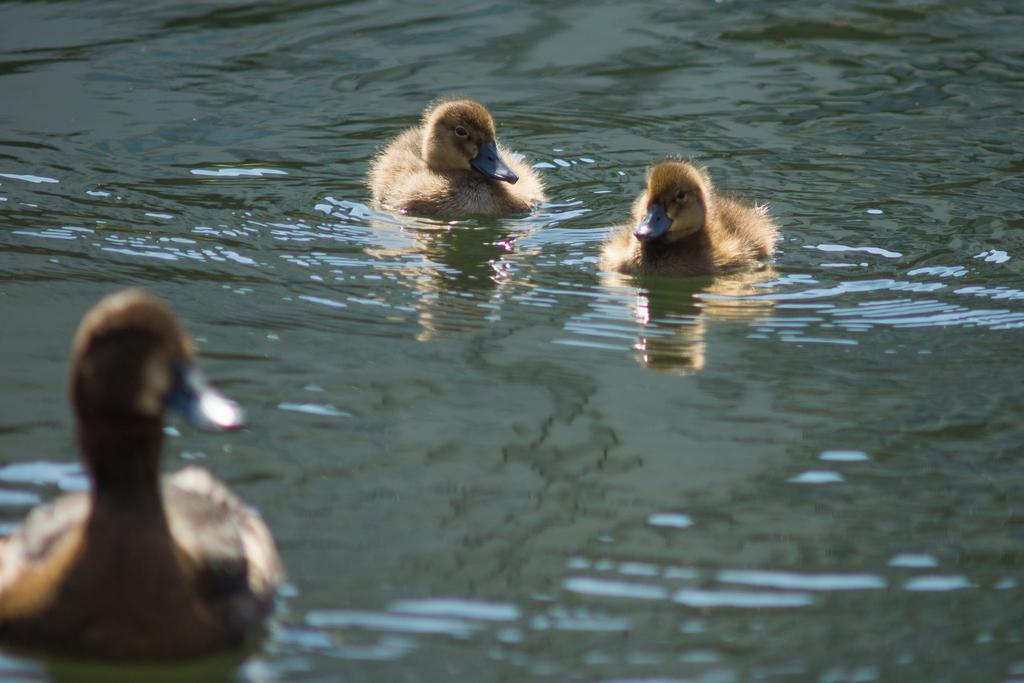What type of animals can be seen in the image? Birds can be seen in the image. Where are the birds situated in the image? The birds are in the water. What advice do the children in the image give to the birds? There are no children present in the image, so there is no advice being given to the birds. 